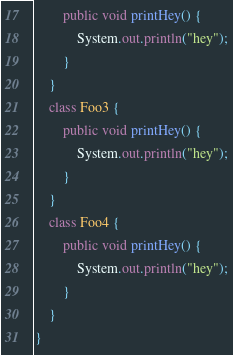Convert code to text. <code><loc_0><loc_0><loc_500><loc_500><_Java_>        public void printHey() {
            System.out.println("hey");
        }
    }
    class Foo3 {
        public void printHey() {
            System.out.println("hey");
        }
    }
    class Foo4 {
        public void printHey() {
            System.out.println("hey");
        }
    }
}
</code> 